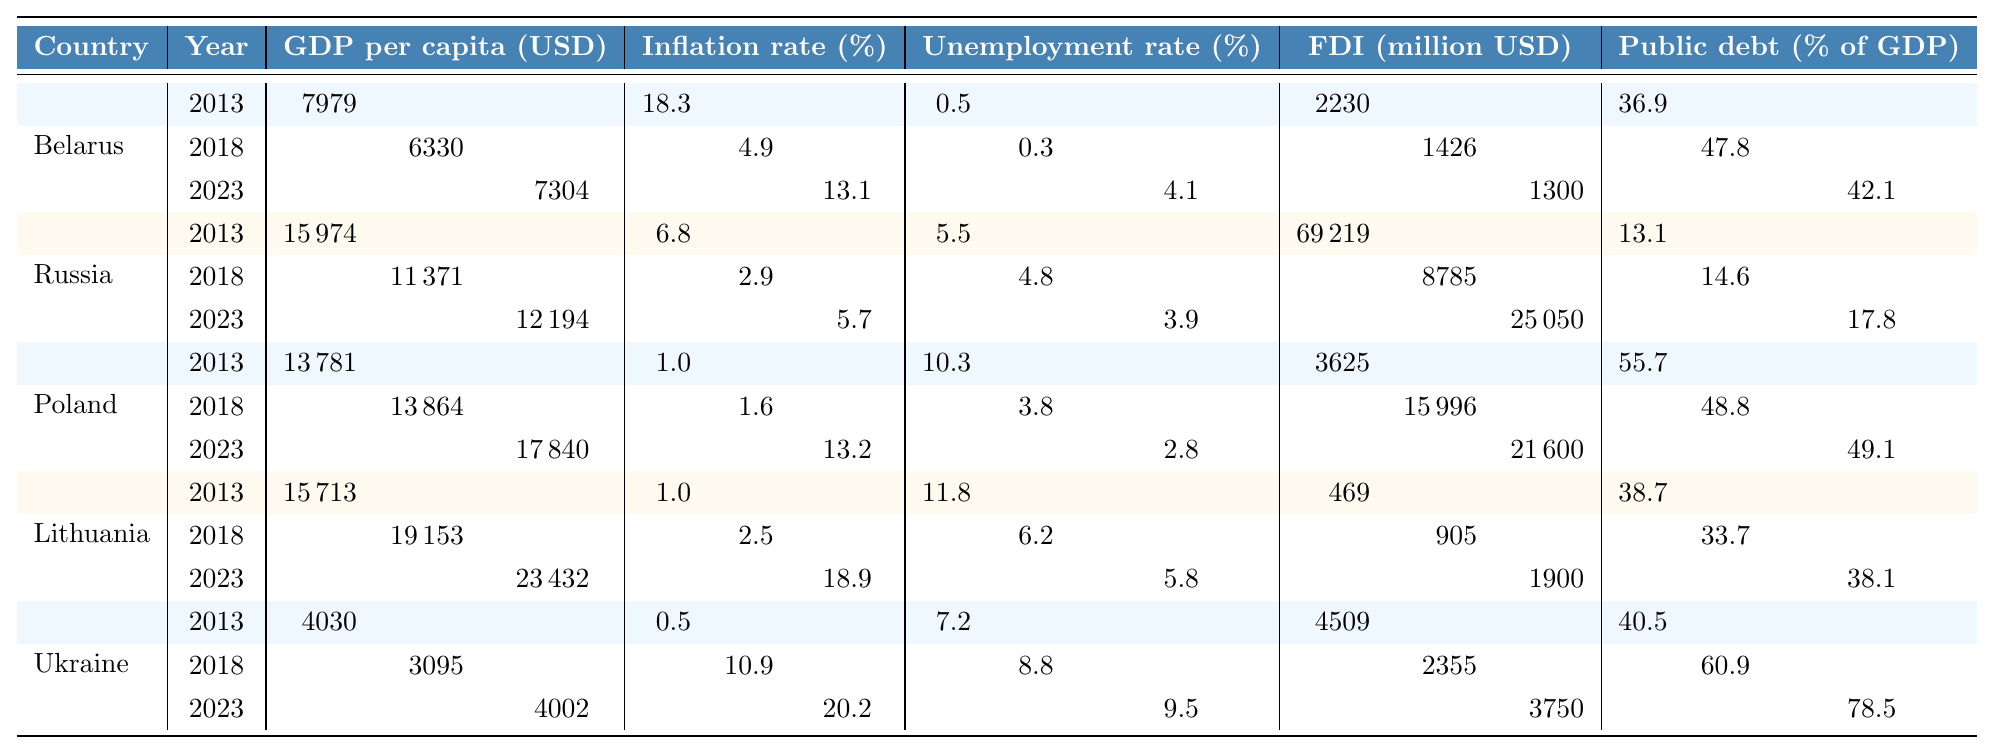What was the GDP per capita for Belarus in 2023? The table shows the GDP per capita for Belarus in 2023 as 7304 USD.
Answer: 7304 USD Which country had the lowest inflation rate in 2013? From the inflation rates provided, Ukraine had the lowest inflation rate at 0.5% in 2013.
Answer: Ukraine What is the change in the unemployment rate for Belarus from 2013 to 2023? The unemployment rate for Belarus in 2013 was 0.5% and increased to 4.1% in 2023, giving a change of 4.1% - 0.5% = 3.6%.
Answer: 3.6% What was the total foreign direct investment (FDI) for Russia from 2013 to 2023? The FDI for Russia in 2013 was 69219 million USD, in 2018 it was 8785 million USD, and in 2023 it was 25050 million USD. Summing these gives a total of 69219 + 8785 + 25050 = 106054 million USD.
Answer: 106054 million USD Which country had the highest GDP per capita in 2023, and what was the value? Lithuania had the highest GDP per capita in 2023 at 23432 USD. I confirmed by checking the values for all countries in 2023.
Answer: Lithuania, 23432 USD Is it true that the inflation rate in Poland was higher than in Belarus in 2023? In 2023, Poland's inflation rate was 13.2% and Belarus's was 13.1%. Since 13.2% > 13.1%, this statement is true.
Answer: Yes What is the average GDP per capita for Ukraine over the three years provided? The GDP per capita for Ukraine is 4030 USD (2013), 3095 USD (2018), and 4002 USD (2023). Summing them gives 4030 + 3095 + 4002 = 11127, and dividing by 3 gives 11127 / 3 = 3709.
Answer: 3709 USD By how much did the public debt as a percentage of GDP increase in Ukraine from 2013 to 2023? Ukraine's public debt was 40.5% in 2013 and increased to 78.5% in 2023. The increase is calculated as 78.5% - 40.5% = 38%.
Answer: 38% Which country saw the largest decrease in GDP per capita from 2013 to 2018? In Belarus, GDP per capita decreased from 7979 USD in 2013 to 6330 USD in 2018, a decrease of 1649 USD. Comparing with other countries, Russia had a decrease of 4603 USD. Thus, Russia had the largest decrease.
Answer: Russia What was the public debt percentage in Lithuania in 2018, and was it below 40%? In the table, Lithuania's public debt as a percentage of GDP in 2018 was 33.7%. Since 33.7% is below 40%, the statement is true.
Answer: Yes 